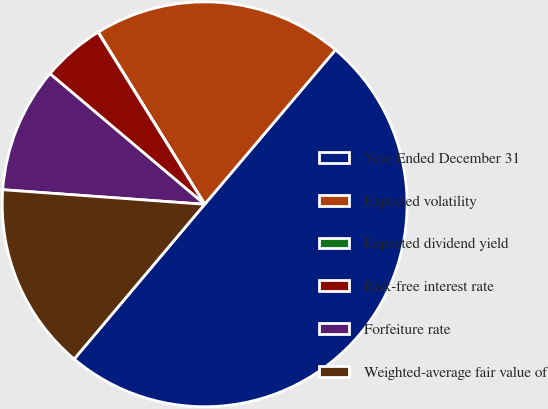<chart> <loc_0><loc_0><loc_500><loc_500><pie_chart><fcel>Year Ended December 31<fcel>Expected volatility<fcel>Expected dividend yield<fcel>Risk-free interest rate<fcel>Forfeiture rate<fcel>Weighted-average fair value of<nl><fcel>49.96%<fcel>20.0%<fcel>0.02%<fcel>5.01%<fcel>10.01%<fcel>15.0%<nl></chart> 